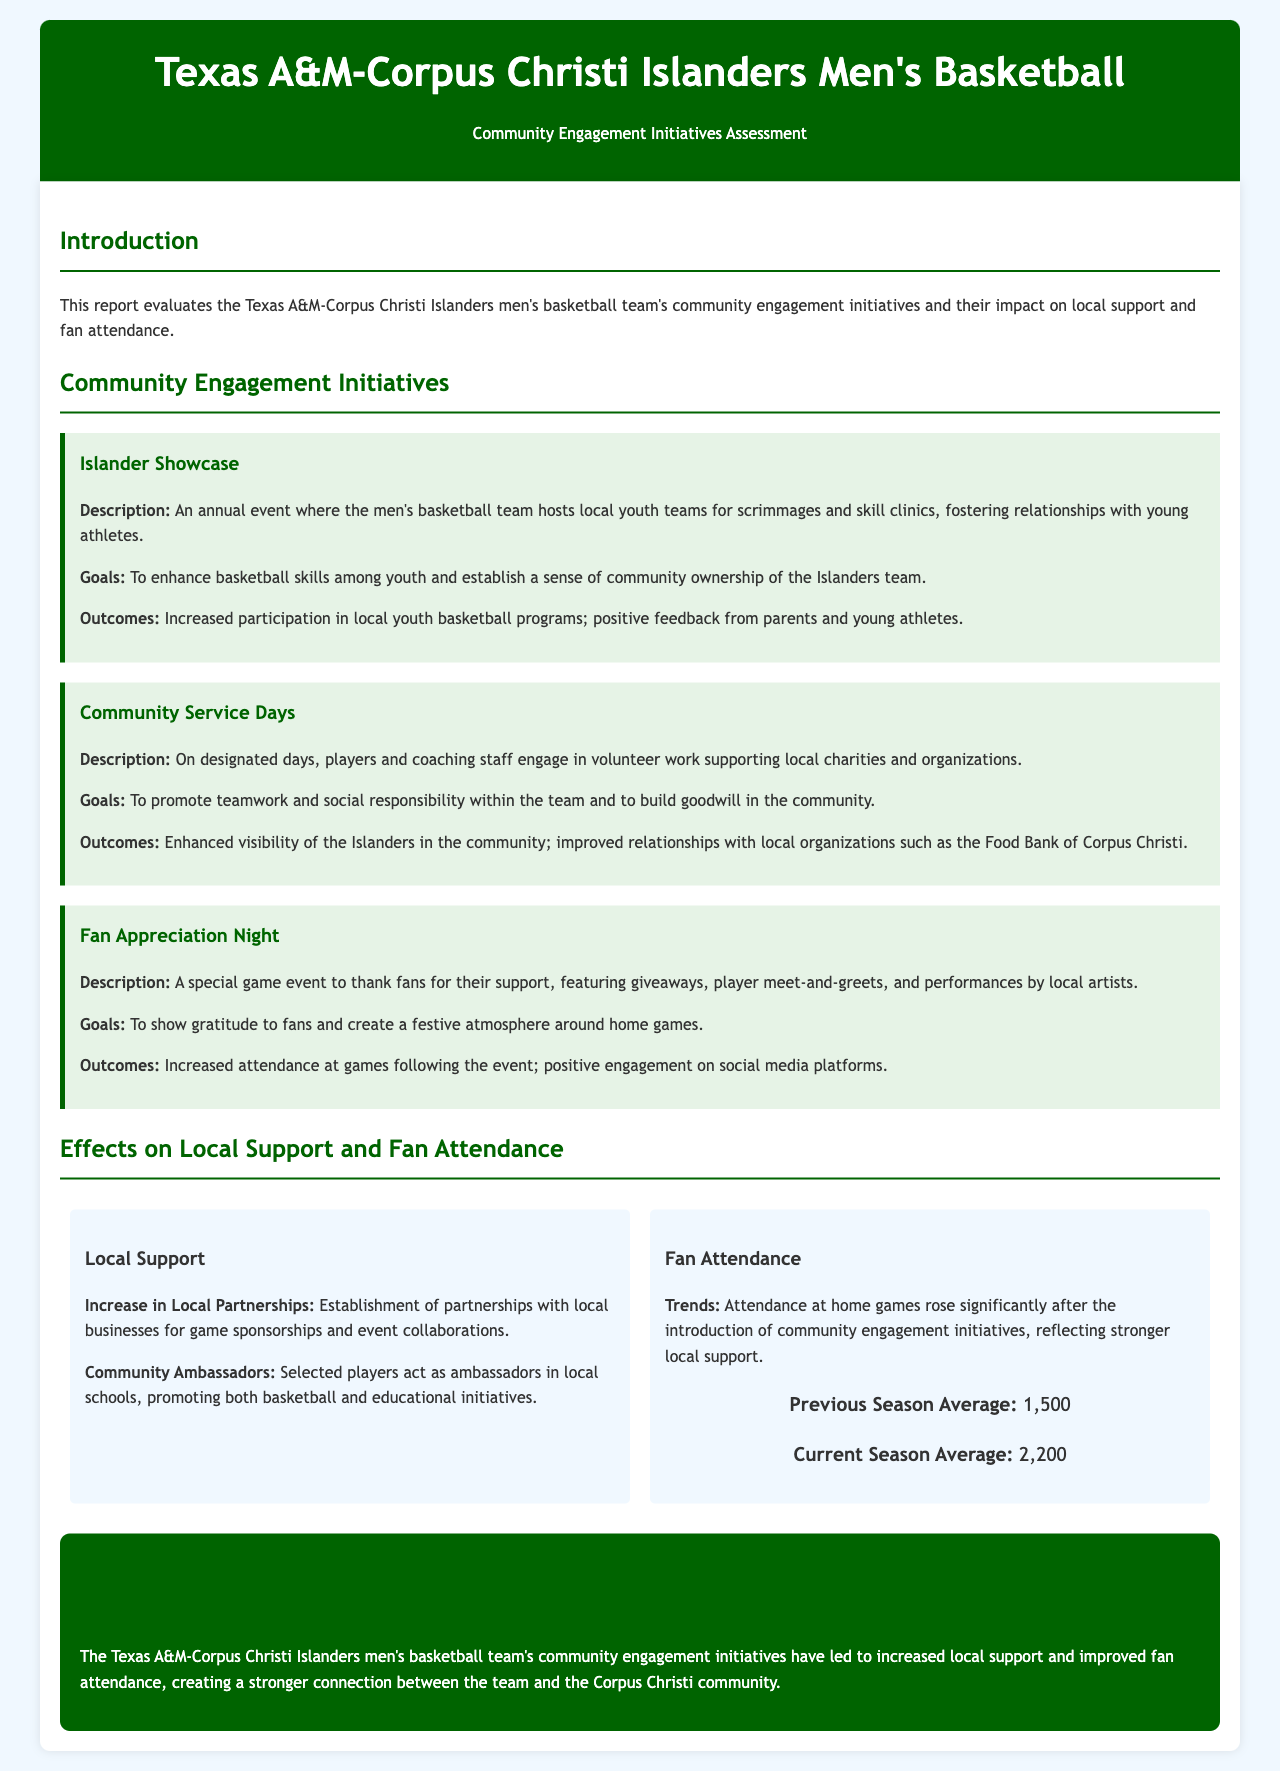what is the title of the report? The title of the report is explicitly stated in the header section of the document.
Answer: Texas A&M-Corpus Christi Islanders Men's Basketball: Community Engagement Assessment what is the goal of the Islander Showcase initiative? The goal of the Islander Showcase initiative is mentioned under its description, highlighting the objective of the event.
Answer: To enhance basketball skills among youth and establish a sense of community ownership of the Islanders team how many community engagement initiatives are listed in the report? The report includes a section that details the various initiatives undertaken by the team.
Answer: Three what was the previous season average attendance at home games? The statistics section provides a direct comparison between the previous and current season attendance numbers.
Answer: 1,500 what is the current season average attendance at home games? The statistics section provides a direct comparison between the previous and current season attendance numbers.
Answer: 2,200 what is one outcome of the Community Service Days initiative? The outcomes of each initiative are provided in detail, indicating the impact they had on the community.
Answer: Enhanced visibility of the Islanders in the community which initiative involved player meet-and-greets? The report describes the Fan Appreciation Night initiative, where player interactions occur.
Answer: Fan Appreciation Night what color is used for the header background? The document style specifies the color used for the header, which is a key visual aspect.
Answer: Dark green what is one way local support increased according to the document? The document mentions various ways local support has improved following engagement initiatives.
Answer: Establishment of partnerships with local businesses for game sponsorships and event collaborations 